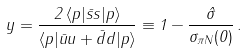<formula> <loc_0><loc_0><loc_500><loc_500>y = \frac { 2 \, \langle p | \bar { s } s | p \rangle } { \langle p | \bar { u } u + \bar { d } d | p \rangle } \equiv 1 - \frac { \hat { \sigma } } { \sigma _ { \pi N } ( 0 ) } \, .</formula> 